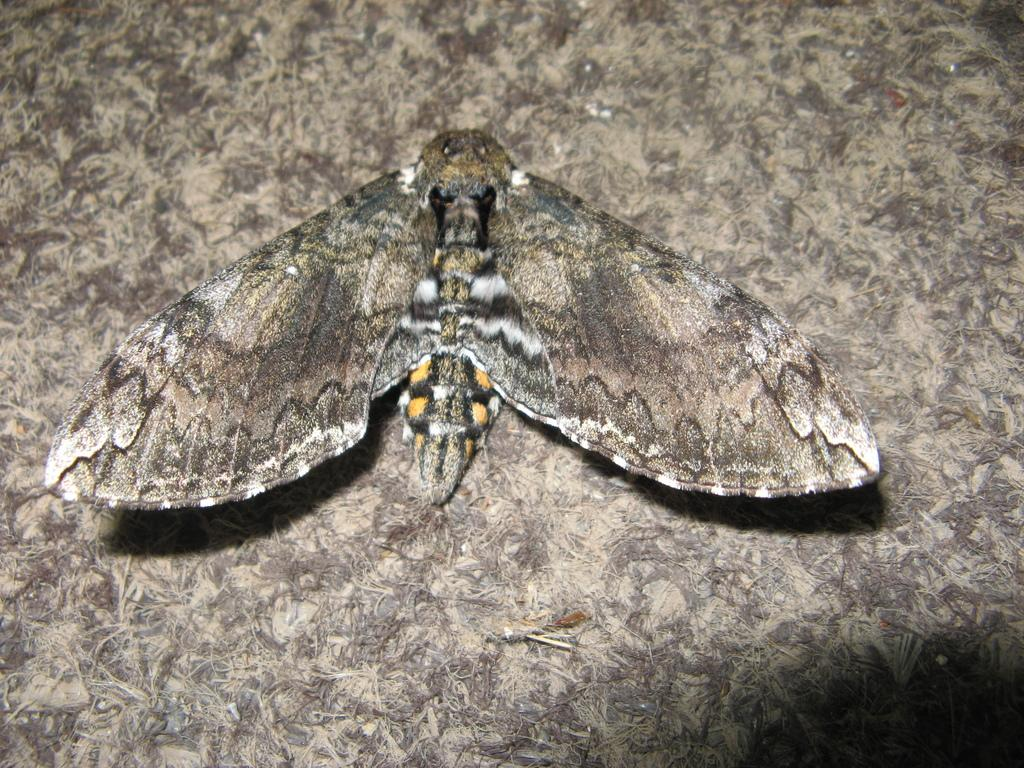What type of creature is in the picture? There is an insect in the picture. What features does the insect have? The insect has wings and a body. What color is the background in the image? The backdrop surface is gray. What type of apparel is the insect wearing in the image? There is no apparel present on the insect in the image, as insects do not wear clothing. 